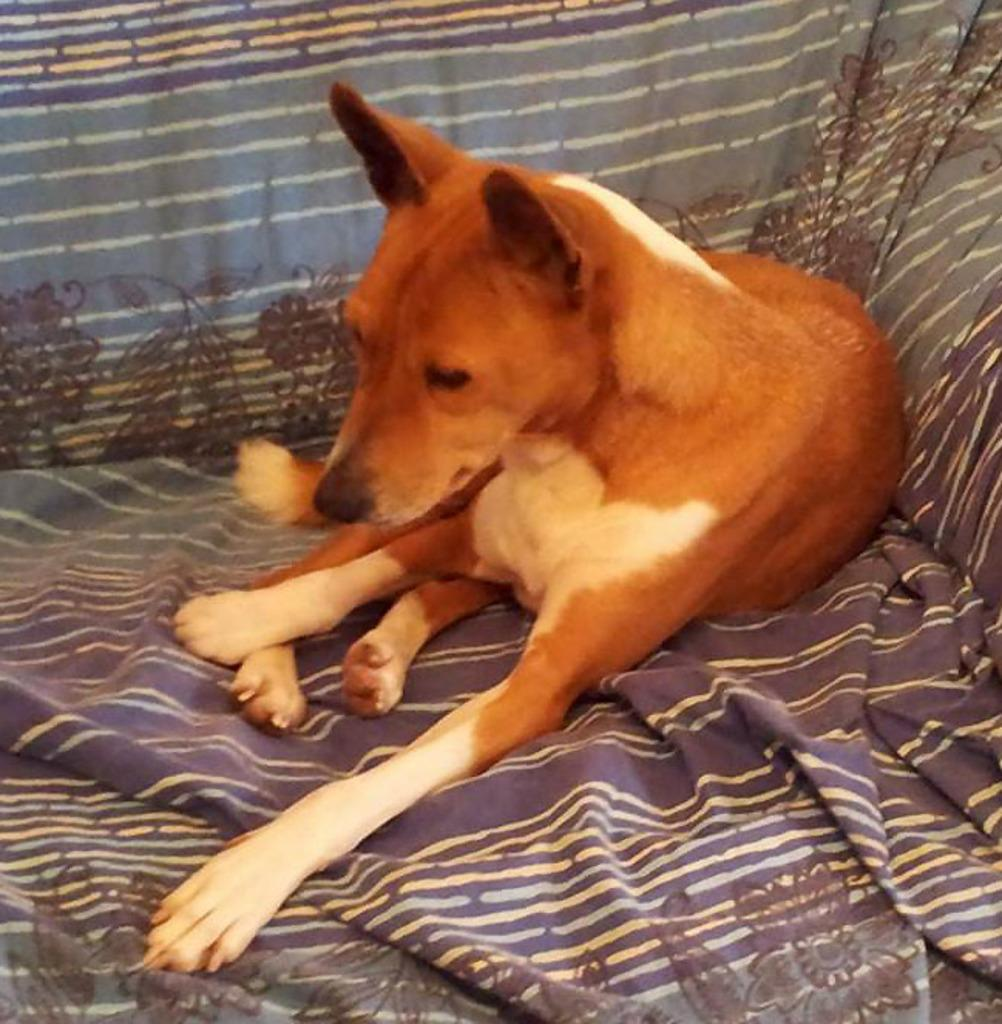What animal can be seen in the image? There is a dog in the image. Where is the dog located in the image? The dog is sitting on a sofa. What type of lunchroom is visible in the image? There is no lunchroom present in the image; it features a dog sitting on a sofa. How many passengers are visible in the image? There are no passengers present in the image; it features a dog sitting on a sofa. 